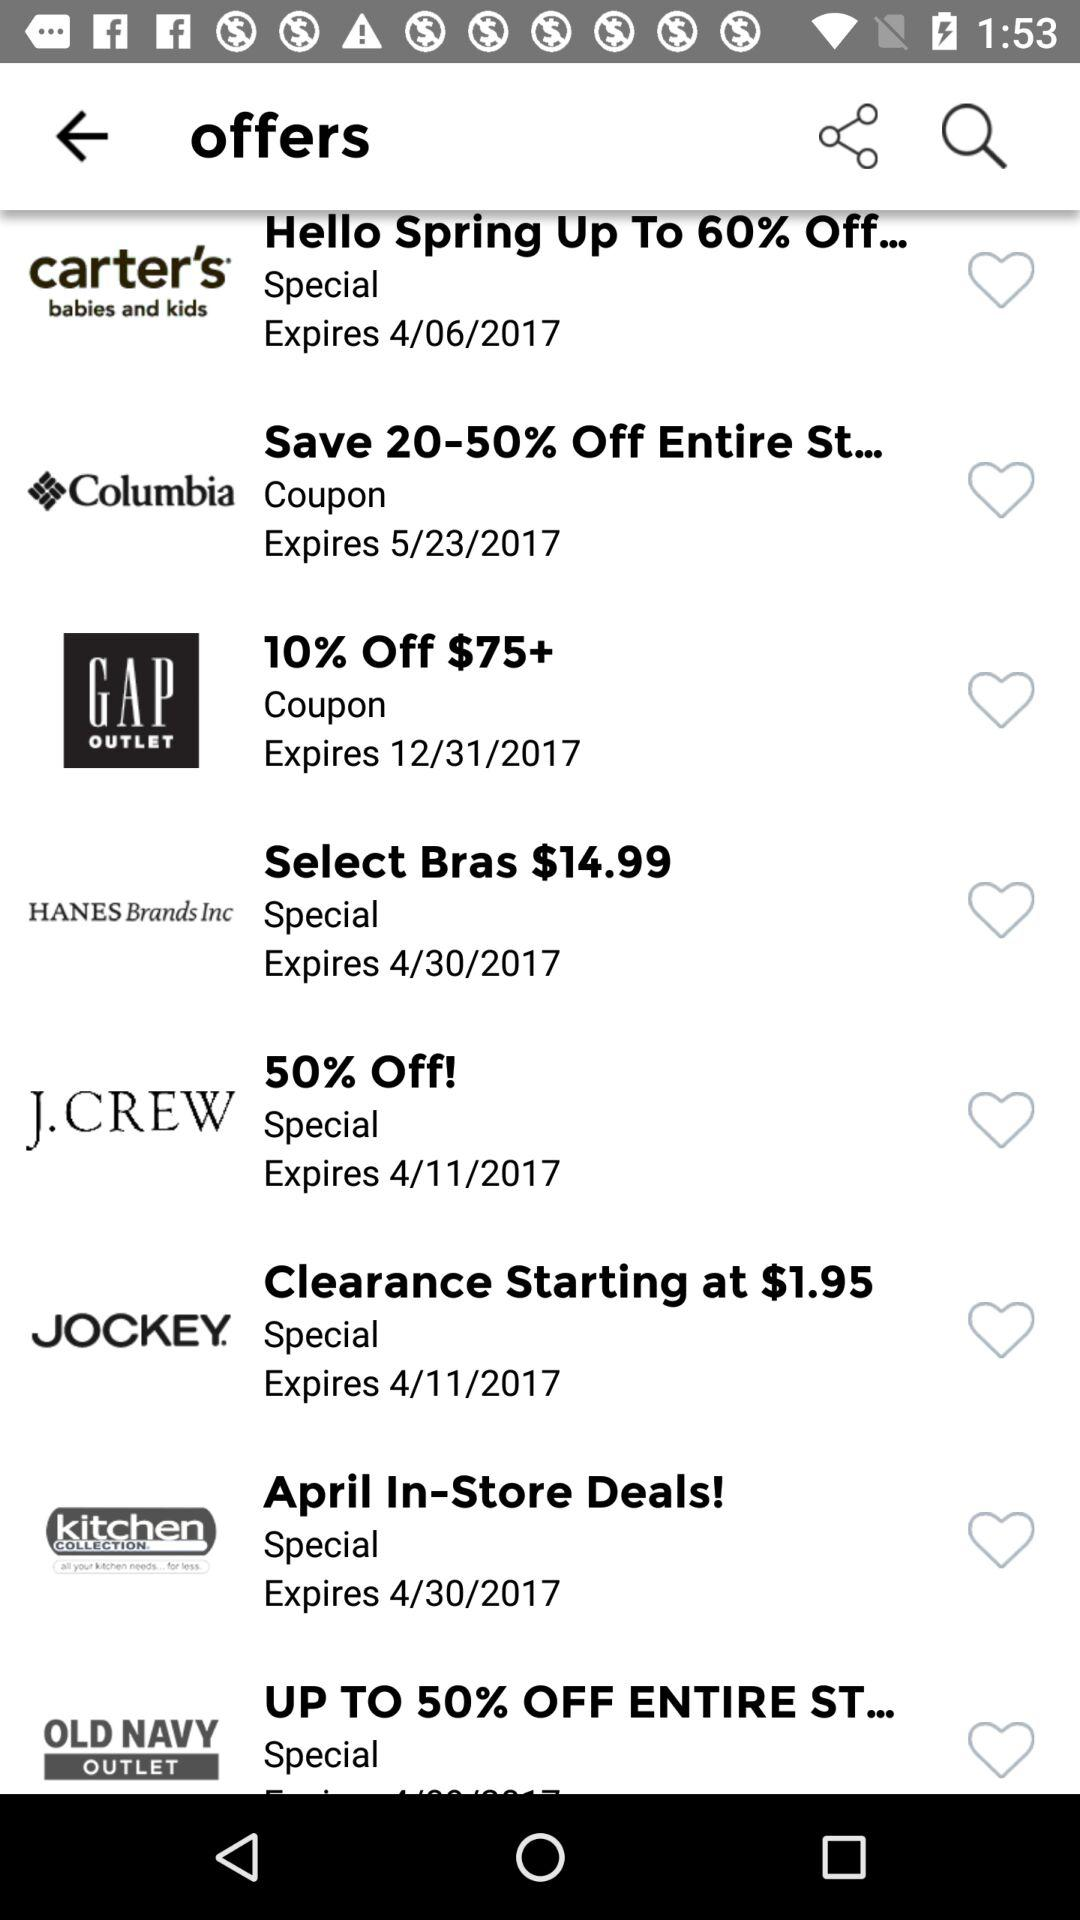What is the offer given by the "OLD NAVY OUTLET"? The offer is up to 50% off. 